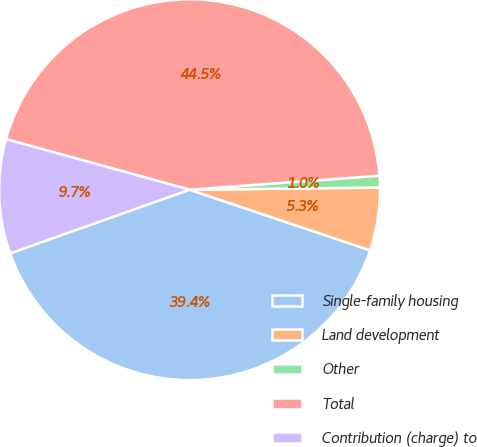Convert chart to OTSL. <chart><loc_0><loc_0><loc_500><loc_500><pie_chart><fcel>Single-family housing<fcel>Land development<fcel>Other<fcel>Total<fcel>Contribution (charge) to<nl><fcel>39.42%<fcel>5.34%<fcel>0.99%<fcel>44.55%<fcel>9.7%<nl></chart> 